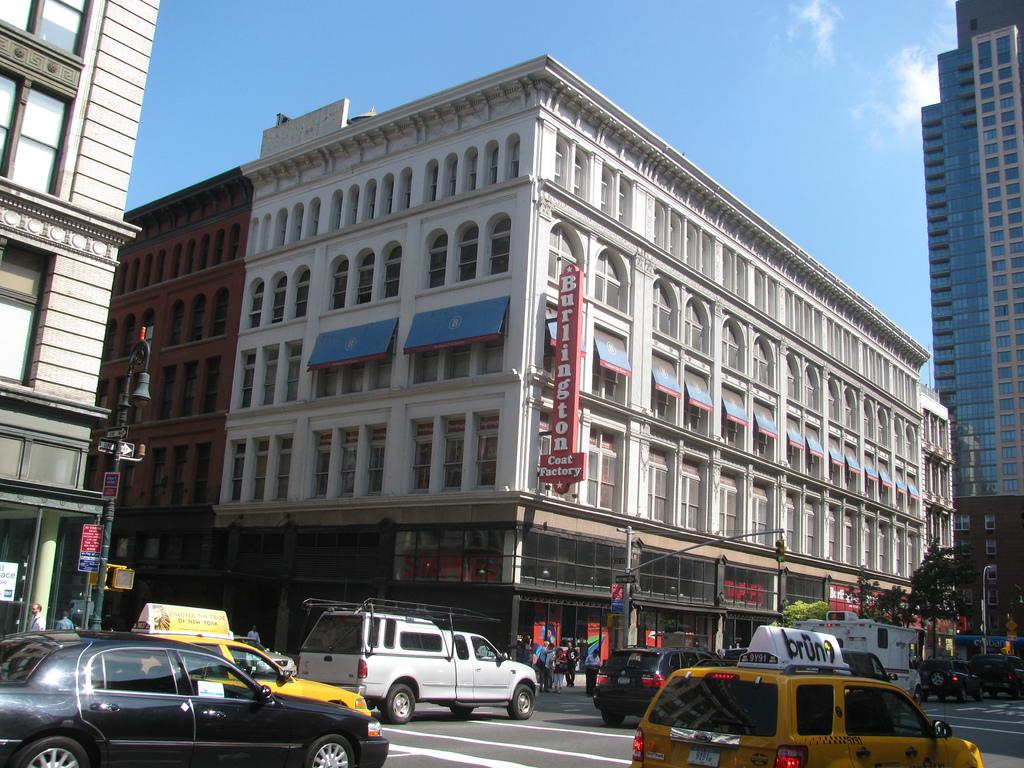What store is shown in this area?
Keep it short and to the point. Burlington coat factory. What does the store make?
Your response must be concise. Coats. 